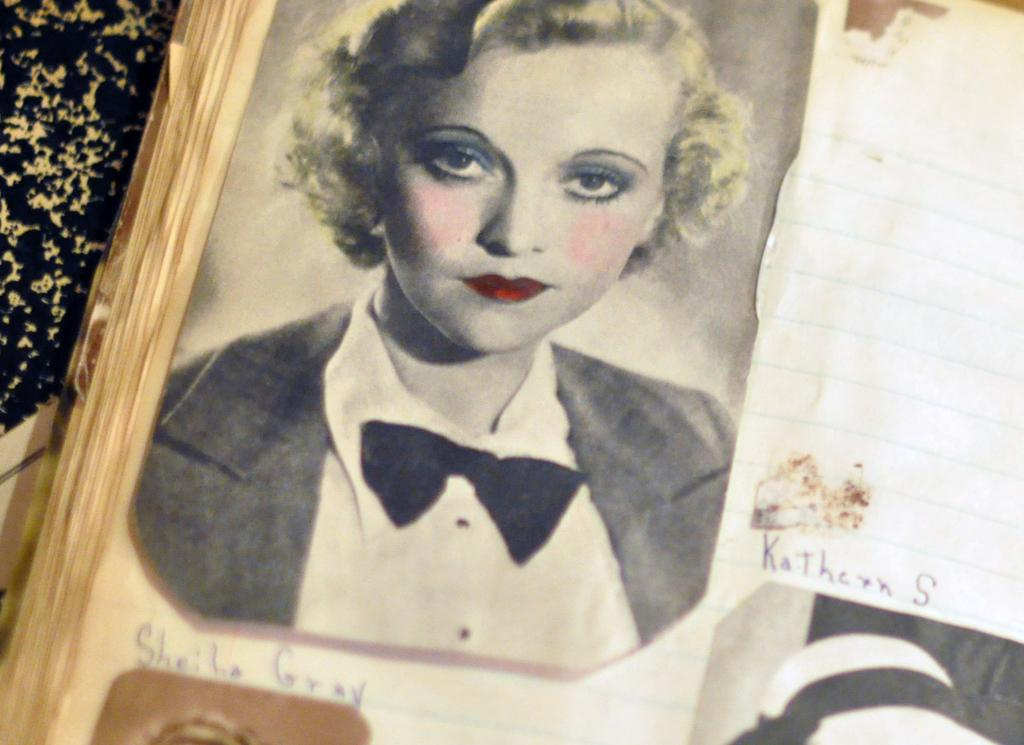What object is present in the image that typically holds photos or artwork? There is a photo frame in the image. What is displayed within the photo frame? The photo frame contains images and text. What type of vegetation can be seen on the left side of the image? There are plants on the left side of the image. What type of unit is being delivered to the location in the image? There is no indication of a unit being delivered in the image; it only features a photo frame and plants. Is there any eggnog visible in the image? There is no eggnog present in the image. 